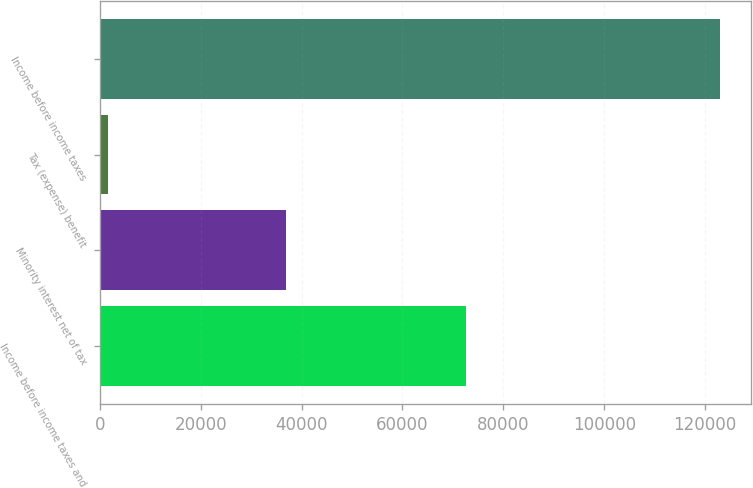Convert chart. <chart><loc_0><loc_0><loc_500><loc_500><bar_chart><fcel>Income before income taxes and<fcel>Minority interest net of tax<fcel>Tax (expense) benefit<fcel>Income before income taxes<nl><fcel>72529<fcel>36961<fcel>1622<fcel>122844<nl></chart> 